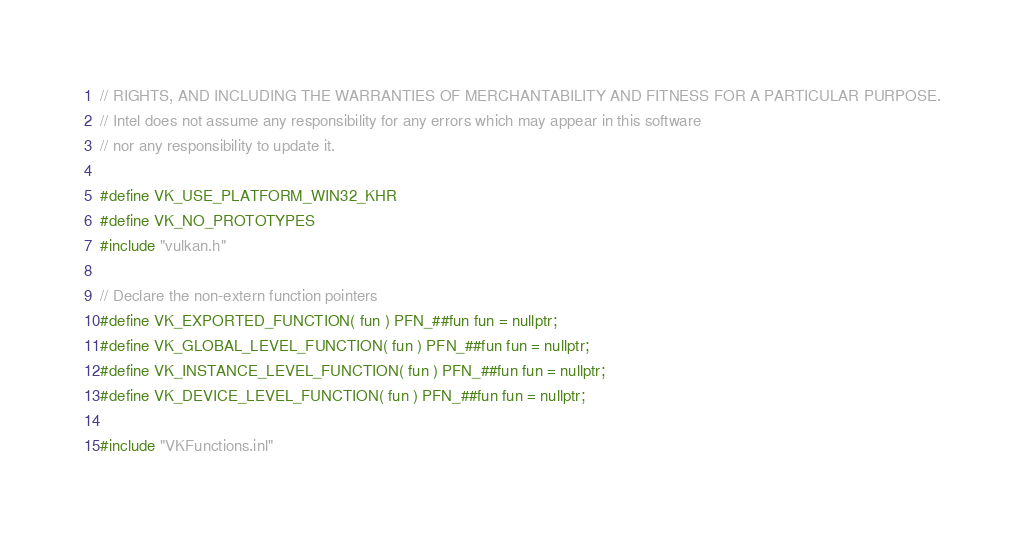Convert code to text. <code><loc_0><loc_0><loc_500><loc_500><_C++_>// RIGHTS, AND INCLUDING THE WARRANTIES OF MERCHANTABILITY AND FITNESS FOR A PARTICULAR PURPOSE.
// Intel does not assume any responsibility for any errors which may appear in this software
// nor any responsibility to update it.

#define VK_USE_PLATFORM_WIN32_KHR
#define VK_NO_PROTOTYPES
#include "vulkan.h"

// Declare the non-extern function pointers
#define VK_EXPORTED_FUNCTION( fun ) PFN_##fun fun = nullptr;
#define VK_GLOBAL_LEVEL_FUNCTION( fun ) PFN_##fun fun = nullptr;
#define VK_INSTANCE_LEVEL_FUNCTION( fun ) PFN_##fun fun = nullptr;
#define VK_DEVICE_LEVEL_FUNCTION( fun ) PFN_##fun fun = nullptr;

#include "VKFunctions.inl"
</code> 